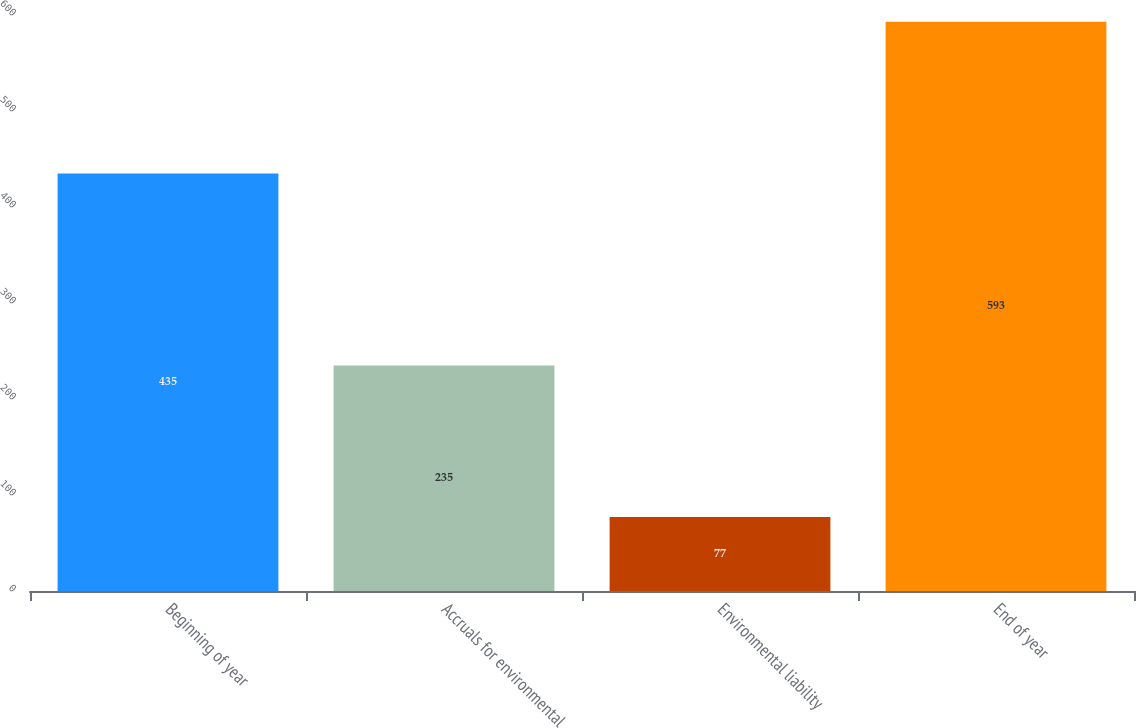Convert chart. <chart><loc_0><loc_0><loc_500><loc_500><bar_chart><fcel>Beginning of year<fcel>Accruals for environmental<fcel>Environmental liability<fcel>End of year<nl><fcel>435<fcel>235<fcel>77<fcel>593<nl></chart> 